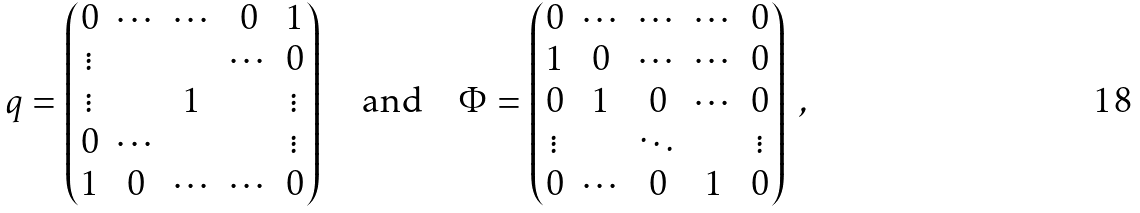Convert formula to latex. <formula><loc_0><loc_0><loc_500><loc_500>q = \begin{pmatrix} 0 & \cdots & \cdots & 0 & 1 \\ \vdots & & & \cdots & 0 \\ \vdots & & 1 & & \vdots \\ 0 & \cdots & & & \vdots \\ 1 & 0 & \cdots & \cdots & 0 \end{pmatrix} \quad \text {and} \quad \Phi = \begin{pmatrix} 0 & \cdots & \cdots & \cdots & 0 \\ 1 & 0 & \cdots & \cdots & 0 \\ 0 & 1 & 0 & \cdots & 0 \\ \vdots & & \ddots & & \vdots \\ 0 & \cdots & 0 & 1 & 0 \end{pmatrix} \ ,</formula> 